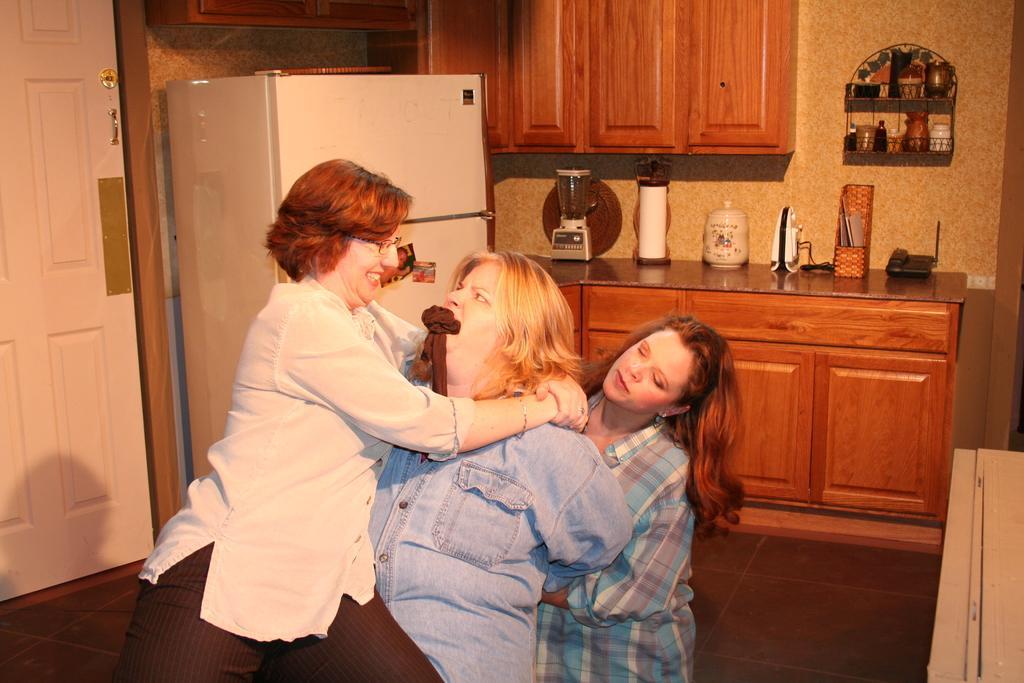How would you summarize this image in a sentence or two? In this image I can see three women's on the floor. In the background I can see a kitchen cabinet, grinder, kitchen tools, refrigerator, door and shelves. This image is taken may be in a room. 